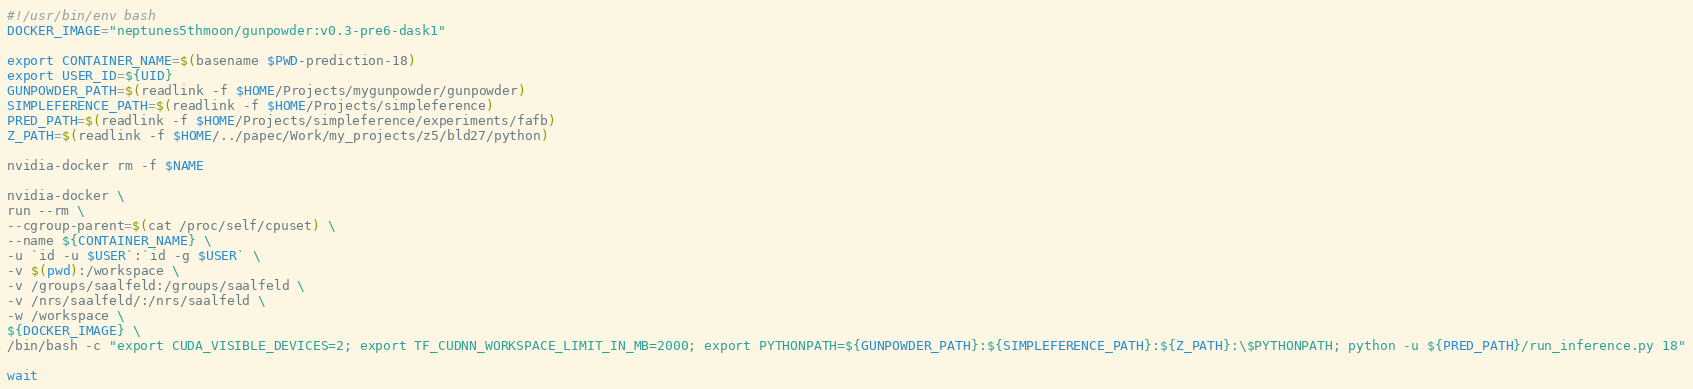<code> <loc_0><loc_0><loc_500><loc_500><_Bash_>#!/usr/bin/env bash 
DOCKER_IMAGE="neptunes5thmoon/gunpowder:v0.3-pre6-dask1" 

export CONTAINER_NAME=$(basename $PWD-prediction-18)
export USER_ID=${UID}
GUNPOWDER_PATH=$(readlink -f $HOME/Projects/mygunpowder/gunpowder)
SIMPLEFERENCE_PATH=$(readlink -f $HOME/Projects/simpleference)
PRED_PATH=$(readlink -f $HOME/Projects/simpleference/experiments/fafb)
Z_PATH=$(readlink -f $HOME/../papec/Work/my_projects/z5/bld27/python)

nvidia-docker rm -f $NAME

nvidia-docker \
run --rm \
--cgroup-parent=$(cat /proc/self/cpuset) \
--name ${CONTAINER_NAME} \
-u `id -u $USER`:`id -g $USER` \
-v $(pwd):/workspace \
-v /groups/saalfeld:/groups/saalfeld \
-v /nrs/saalfeld/:/nrs/saalfeld \
-w /workspace \
${DOCKER_IMAGE} \
/bin/bash -c "export CUDA_VISIBLE_DEVICES=2; export TF_CUDNN_WORKSPACE_LIMIT_IN_MB=2000; export PYTHONPATH=${GUNPOWDER_PATH}:${SIMPLEFERENCE_PATH}:${Z_PATH}:\$PYTHONPATH; python -u ${PRED_PATH}/run_inference.py 18"

wait
</code> 